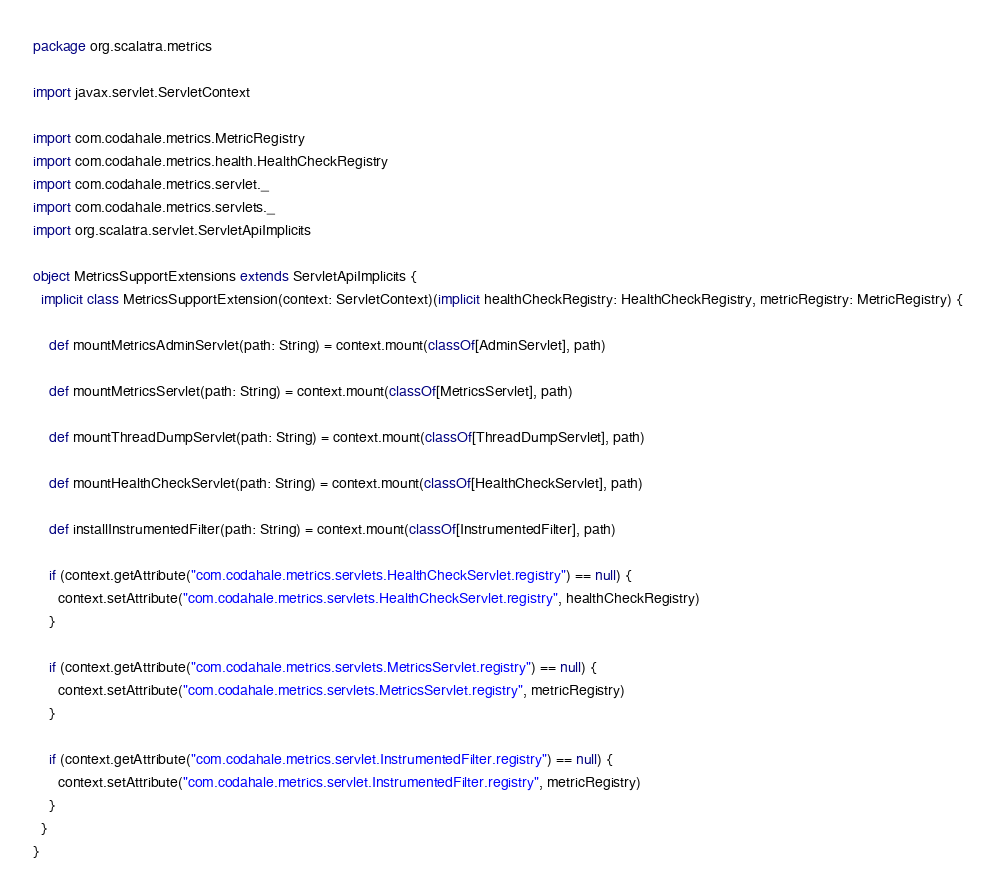<code> <loc_0><loc_0><loc_500><loc_500><_Scala_>package org.scalatra.metrics

import javax.servlet.ServletContext

import com.codahale.metrics.MetricRegistry
import com.codahale.metrics.health.HealthCheckRegistry
import com.codahale.metrics.servlet._
import com.codahale.metrics.servlets._
import org.scalatra.servlet.ServletApiImplicits

object MetricsSupportExtensions extends ServletApiImplicits {
  implicit class MetricsSupportExtension(context: ServletContext)(implicit healthCheckRegistry: HealthCheckRegistry, metricRegistry: MetricRegistry) {

    def mountMetricsAdminServlet(path: String) = context.mount(classOf[AdminServlet], path)

    def mountMetricsServlet(path: String) = context.mount(classOf[MetricsServlet], path)

    def mountThreadDumpServlet(path: String) = context.mount(classOf[ThreadDumpServlet], path)

    def mountHealthCheckServlet(path: String) = context.mount(classOf[HealthCheckServlet], path)

    def installInstrumentedFilter(path: String) = context.mount(classOf[InstrumentedFilter], path)

    if (context.getAttribute("com.codahale.metrics.servlets.HealthCheckServlet.registry") == null) {
      context.setAttribute("com.codahale.metrics.servlets.HealthCheckServlet.registry", healthCheckRegistry)
    }

    if (context.getAttribute("com.codahale.metrics.servlets.MetricsServlet.registry") == null) {
      context.setAttribute("com.codahale.metrics.servlets.MetricsServlet.registry", metricRegistry)
    }

    if (context.getAttribute("com.codahale.metrics.servlet.InstrumentedFilter.registry") == null) {
      context.setAttribute("com.codahale.metrics.servlet.InstrumentedFilter.registry", metricRegistry)
    }
  }
}
</code> 